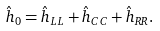Convert formula to latex. <formula><loc_0><loc_0><loc_500><loc_500>\hat { h } _ { 0 } = \hat { h } _ { L L } + \hat { h } _ { C C } + \hat { h } _ { R R } .</formula> 